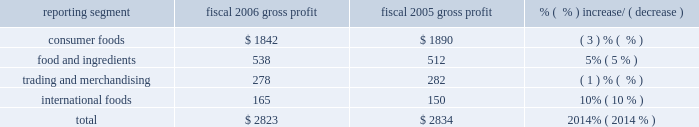Consumer foods net sales decreased $ 94 million for the year to $ 6.5 billion .
Sales volume declined by 1% ( 1 % ) in fiscal 2006 , principally due to declines in certain shelf stable brands .
Sales of the company 2019s top thirty brands , which represented approximately 83% ( 83 % ) of total segment sales during fiscal 2006 , were flat as a group , as sales of some of the company 2019s most significant brands , including chef boyardee ae , marie callender 2019s ae , orville redenbacher 2019s ae , slim jim ae , hebrew national ae , kid cuisine ae , reddi-wip ae , vancamp ae , libby 2019s ae , lachoy ae , the max ae , manwich ae , david 2019s ae , ro*tel ae , angela mia ae , and mama rosa ae grew in fiscal 2006 , but were largely offset by sales declines for the year for hunt 2019s ae , wesson ae , act ii ae , snack pack ae , swiss miss ae , pam ae , egg beaters ae , blue bonnet ae , parkay ae , and rosarita ae .
Food and ingredients net sales increased $ 203 million to $ 3.2 billion , primarily reflecting price increases driven by higher input costs for potato , wheat milling , and dehydrated vegetable operations .
Net sales were also impacted , to a lesser degree , by a 4% ( 4 % ) increase in potato products volume compared to the prior year .
Trading and merchandising net sales decreased $ 38 million to $ 1.2 billion .
The decrease resulted principally from lower grain and edible bean merchandising volume resulting from the divestment or closure of various locations .
International foods net sales increased $ 27 million to $ 603 million .
The strengthening of foreign currencies relative to the u.s .
Dollar accounted for $ 24 million of the increase .
Overall volume growth was modest as the 10% ( 10 % ) volume growth from the top six international brands ( orville redenbacher 2019s ae , act ii ae , snack pack ae , chef boyardee ae , hunt 2019s ae , and pam ae ) , which account for 55% ( 55 % ) of total segment sales , was offset by sales declines related to the discontinuance of a number of low margin products .
Gross profit ( net sales less cost of goods sold ) ( $ in millions ) reporting segment fiscal 2006 gross profit fiscal 2005 gross profit % (  % ) increase/ ( decrease ) .
The company 2019s gross profit for fiscal 2006 was $ 2.8 billion , a decrease of $ 11 million from the prior year , as improvements in the foods and ingredients and international foods segments were more than offset by declines in the consumer foods and trading and merchandising segments .
Gross profit includes $ 20 million of costs associated with the company 2019s restructuring plans in fiscal 2006 , and $ 17 million of costs incurred to implement the company 2019s operational efficiency initiatives in fiscal 2005 .
Consumer foods gross profit for fiscal 2006 was $ 1.8 billion , a decrease of $ 48 million from fiscal 2005 , driven principally by a 2% ( 2 % ) decline in sales volumes .
Fiscal 2006 gross profit includes $ 20 million of costs related to the company 2019s restructuring plan , and fiscal 2005 gross profit includes $ 16 million of costs related to implementing the company 2019s operational efficiency initiatives .
Gross profit was negatively impacted by increased costs of fuel and energy , transportation and warehousing , steel , and other packaging materials in both fiscal 2006 and 2005 .
Food and ingredients gross profit for fiscal 2006 was $ 538 million , an increase of $ 26 million over the prior year .
The gross profit improvement was driven almost entirely by the vegetable processing and dehydration businesses ( including potatoes , garlic , onions , and chili peppers ) as a result of higher volume ( both domestic and export ) , increased value-added sales mix and pricing improvements partially offset by higher raw product and conversion costs. .
What percentage of total gross profit was due to food and ingredients in fiscal 2006? 
Computations: (538 / 2823)
Answer: 0.19058. 